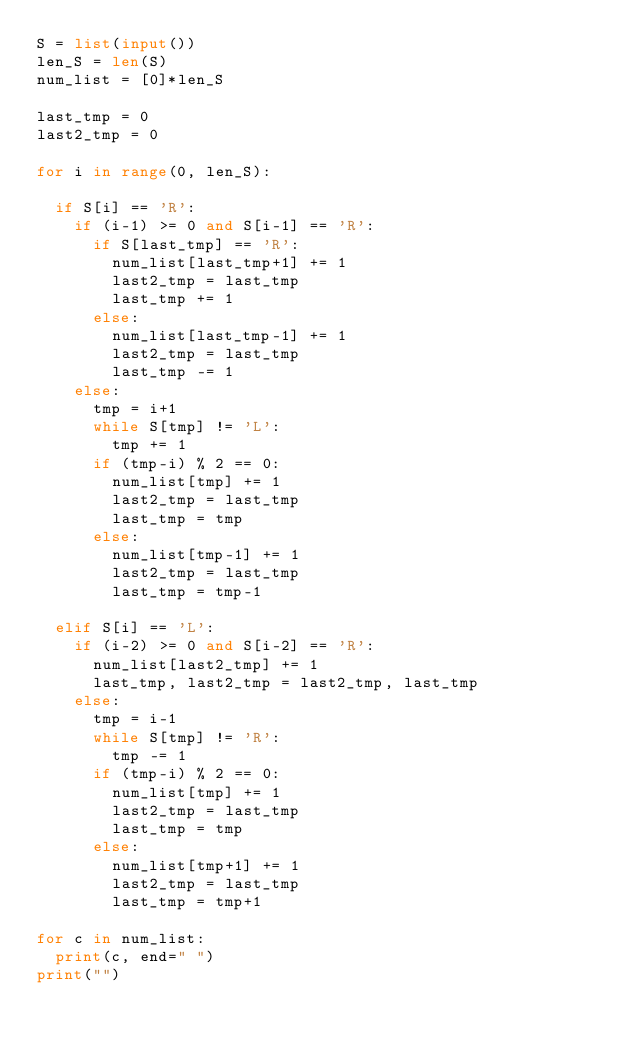<code> <loc_0><loc_0><loc_500><loc_500><_Python_>S = list(input())
len_S = len(S)
num_list = [0]*len_S

last_tmp = 0
last2_tmp = 0

for i in range(0, len_S):

  if S[i] == 'R':
    if (i-1) >= 0 and S[i-1] == 'R':
      if S[last_tmp] == 'R':
        num_list[last_tmp+1] += 1
        last2_tmp = last_tmp
        last_tmp += 1
      else:
        num_list[last_tmp-1] += 1
        last2_tmp = last_tmp
        last_tmp -= 1
    else:
      tmp = i+1
      while S[tmp] != 'L':
        tmp += 1
      if (tmp-i) % 2 == 0:
        num_list[tmp] += 1
        last2_tmp = last_tmp
        last_tmp = tmp
      else:
        num_list[tmp-1] += 1
        last2_tmp = last_tmp
        last_tmp = tmp-1

  elif S[i] == 'L':
    if (i-2) >= 0 and S[i-2] == 'R':
      num_list[last2_tmp] += 1
      last_tmp, last2_tmp = last2_tmp, last_tmp
    else:
      tmp = i-1
      while S[tmp] != 'R':
        tmp -= 1
      if (tmp-i) % 2 == 0:
        num_list[tmp] += 1
        last2_tmp = last_tmp
        last_tmp = tmp
      else:
        num_list[tmp+1] += 1
        last2_tmp = last_tmp
        last_tmp = tmp+1

for c in num_list:
  print(c, end=" ")
print("")
</code> 